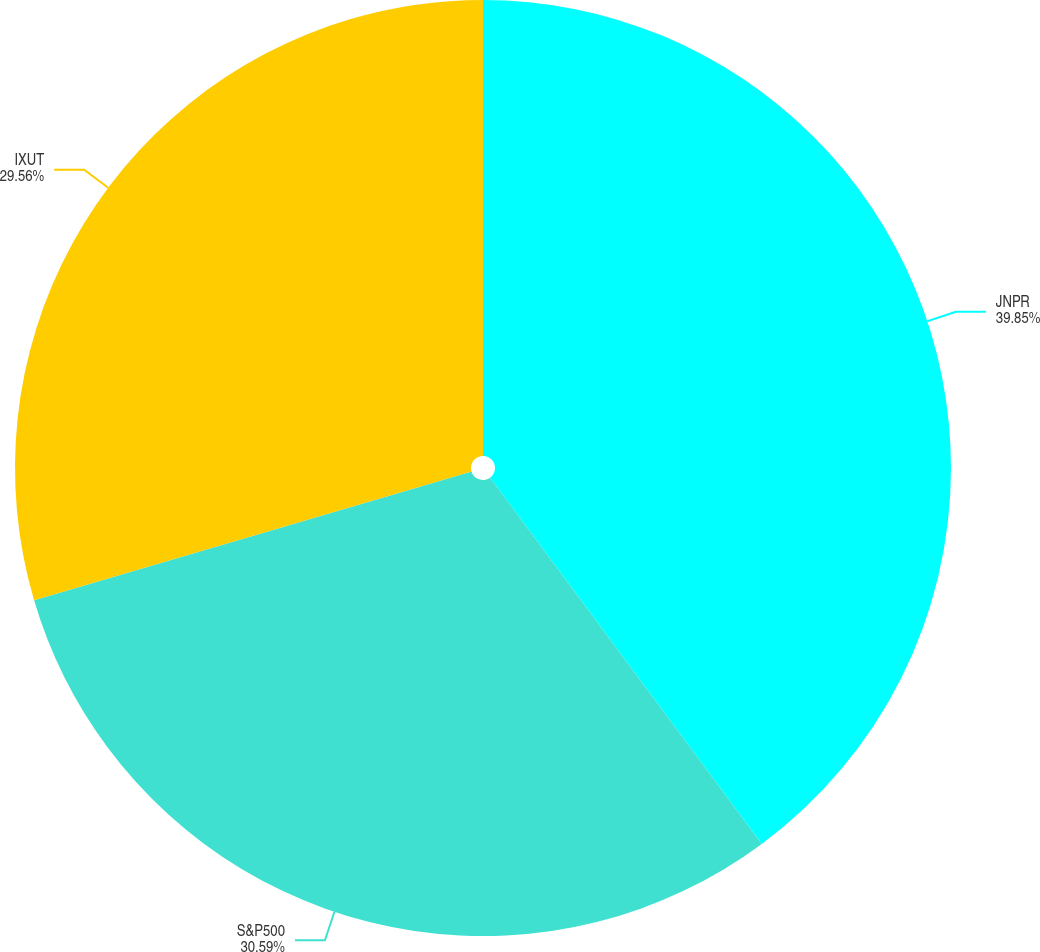Convert chart. <chart><loc_0><loc_0><loc_500><loc_500><pie_chart><fcel>JNPR<fcel>S&P500<fcel>IXUT<nl><fcel>39.84%<fcel>30.59%<fcel>29.56%<nl></chart> 